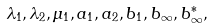Convert formula to latex. <formula><loc_0><loc_0><loc_500><loc_500>\lambda _ { 1 } , \lambda _ { 2 } , \mu _ { 1 } , a _ { 1 } , a _ { 2 } , b _ { 1 } , b _ { \infty } , b _ { \infty } ^ { * } ,</formula> 